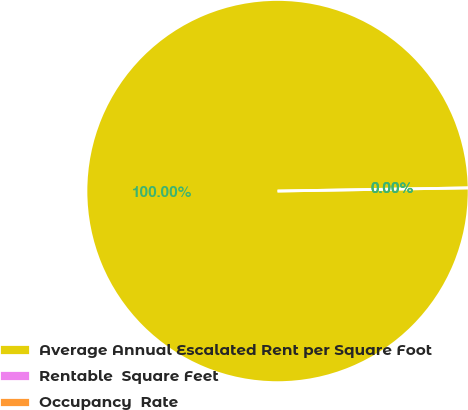Convert chart. <chart><loc_0><loc_0><loc_500><loc_500><pie_chart><fcel>Average Annual Escalated Rent per Square Foot<fcel>Rentable  Square Feet<fcel>Occupancy  Rate<nl><fcel>100.0%<fcel>0.0%<fcel>0.0%<nl></chart> 